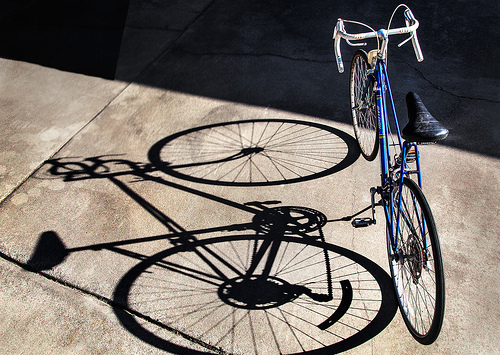<image>
Is there a bike next to the shadow? Yes. The bike is positioned adjacent to the shadow, located nearby in the same general area. 